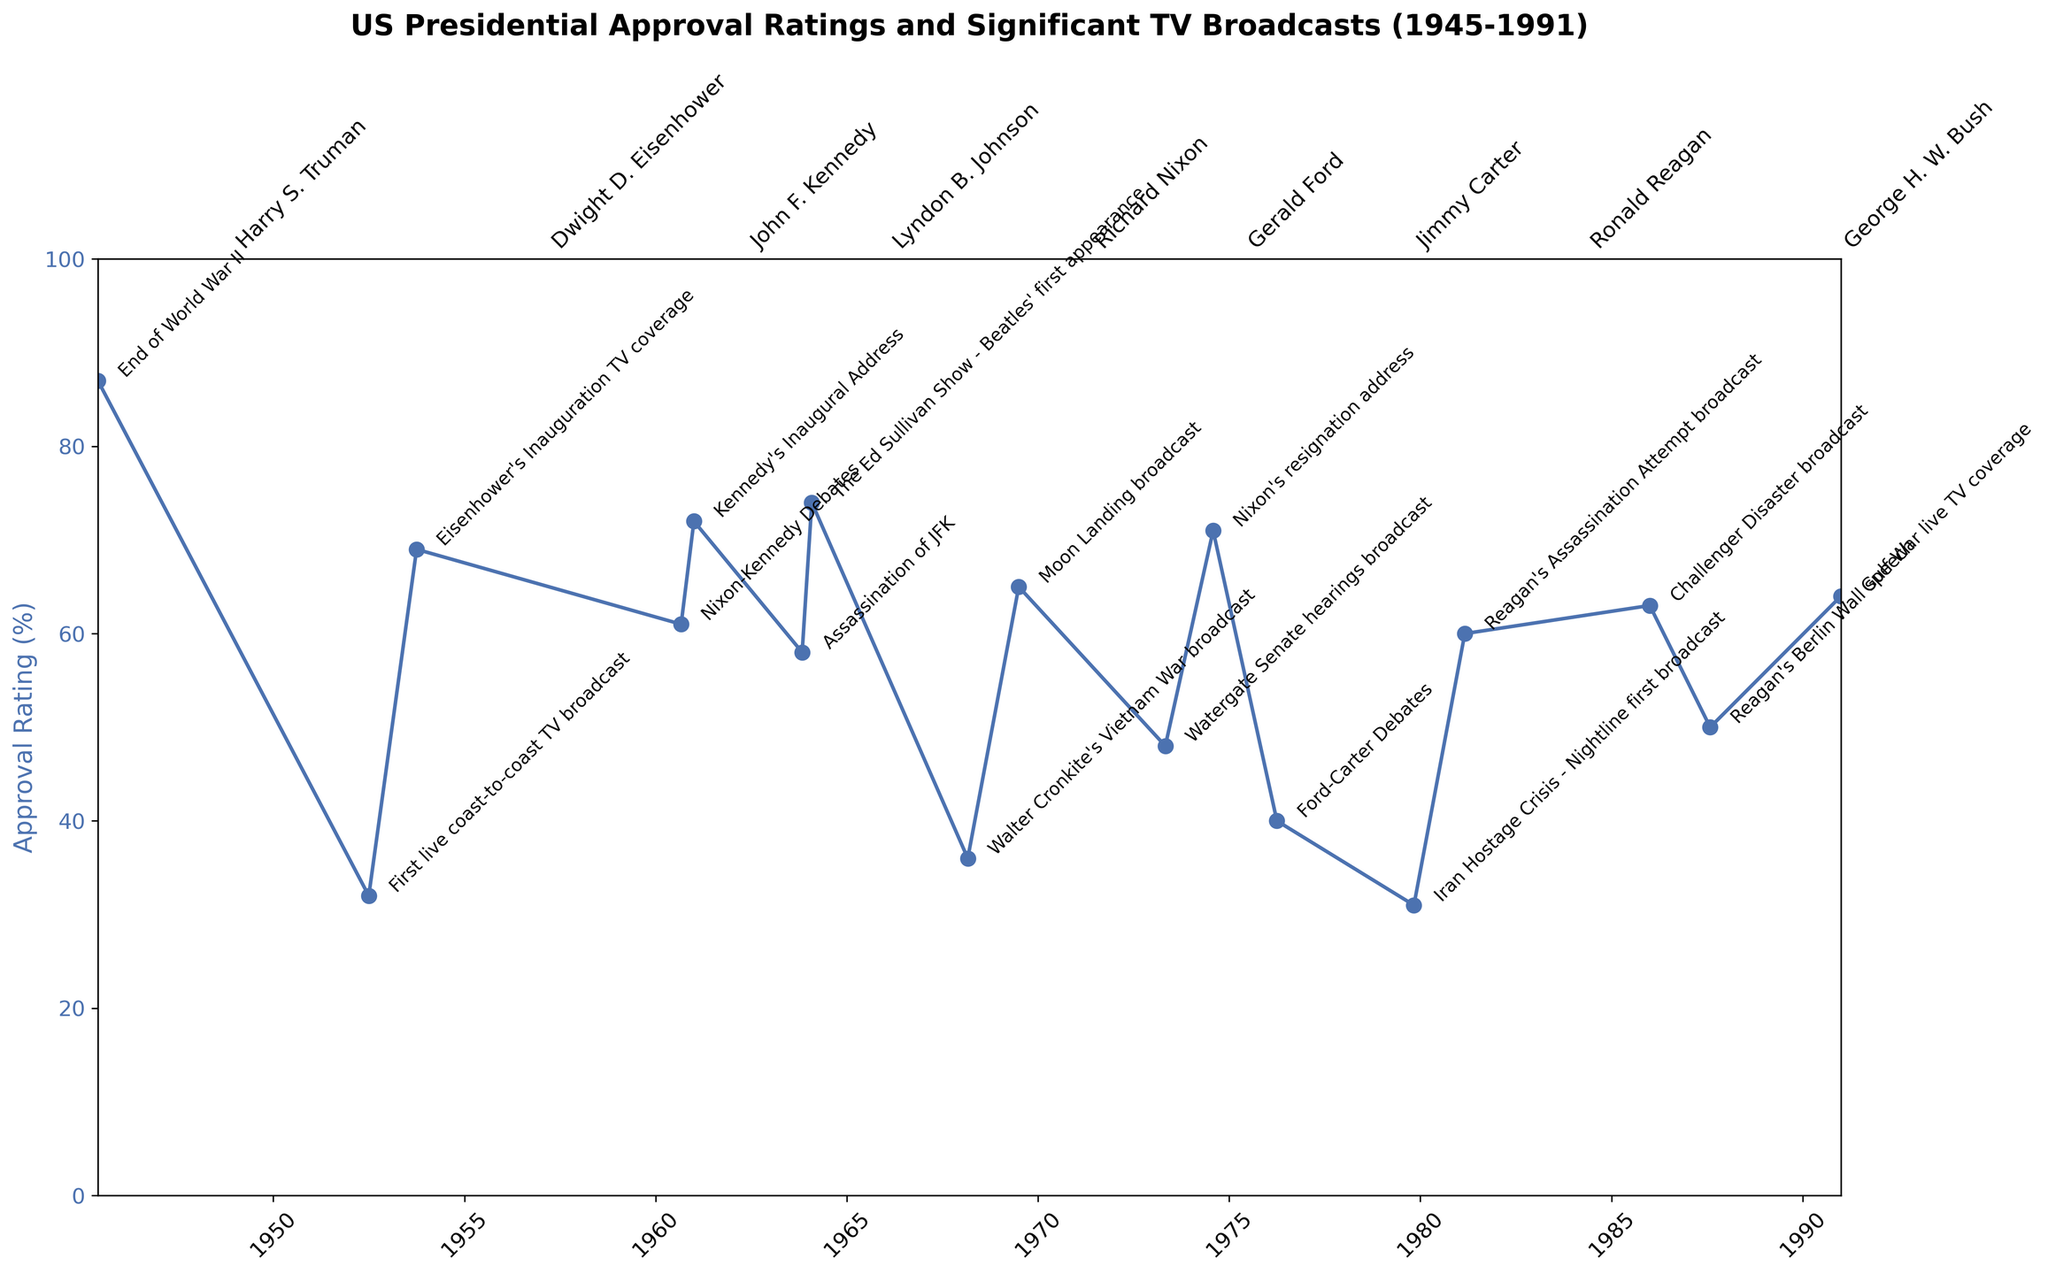How does the approval rating trend vary during different presidencies? To determine this, observe the approval ratings within the time ranges for each president indicated by the annotations. Notice patterns such as increases or decreases in ratings over their respective terms.
Answer: Trends vary for each president Which president experienced the highest approval rating and when? Find the peak point on the approval rating line and identify the president and the corresponding date at that peak. The highest approval rating is 87% for Harry S. Truman in June 1945.
Answer: Harry S. Truman, June 1945 Did the approval rating generally increase or decrease after significant TV broadcasts? Compare the approval ratings before and after each TV broadcast annotation. Note whether the ratings tend to trend upwards or downwards following these events.
Answer: Mixed; depends on the event Which president had the most drastic drop in approval rating, and during what significant broadcast did this occur? Identify the president with the most significant drop by observing the steepest downward slope in the approval rating line. The biggest drop is for Lyndon B. Johnson in March 1968 during Walter Cronkite's Vietnam War broadcast.
Answer: Lyndon B. Johnson, March 1968 What is the average approval rating across the entire timeline? Calculate the sum of all approval ratings and divide by the number of data points to find the average. ($87 + 32 + 69 + 61 + 72 + 58 + 74 + 36 + 65 + 48 + 71 + 40 + 31 + 60 + 63 + 50 + 64) / 17 = 58.12%.
Answer: 58.12% Who was the president during the Moon Landing broadcast and how did the approval rating trend immediately after? Identify the president during the Moon Landing broadcast (July 1969). Observe the approval trend before and after July 1969 for Richard Nixon. The approval rating increased to 65% during the Moon Landing.
Answer: Richard Nixon, increase Which president had the lowest recorded approval rating and what significant event coincided with this? Find the minimum point on the approval rating line and identify the president and significant event. The lowest approval rating is 31% for Jimmy Carter in November 1979 during the Iran Hostage Crisis - Nightline broadcast.
Answer: Jimmy Carter, Iran Hostage Crisis Did Ronald Reagan's approval rating increase after the Challenger Disaster broadcast? Observe the approval rating before and after the January 1986 Challenger Disaster. There was a slight increase to 63%.
Answer: Yes How many unique significant broadcasts are noted in the plot, and how many occurred during Richard Nixon's presidency? Count all unique significant broadcasts labeled in the plot. Then, count the number of those during Nixon's term. There are 17 unique broadcasts, with 3 during Nixon's presidency (Moon Landing, Watergate hearings, Nixon's resignation).
Answer: 17 broadcasts, 3 during Nixon Which president followed John F. Kennedy, and how did the approval ratings differ between them immediately following JFK's assassination? Identify the president after JFK (Lyndon B. Johnson) and compare approval ratings pre- and post-assassination in November 1963. LBJ's rating in February 1964 was 74%, compared to JFK's 58% in November 1963.
Answer: Lyndon B. Johnson, increased 